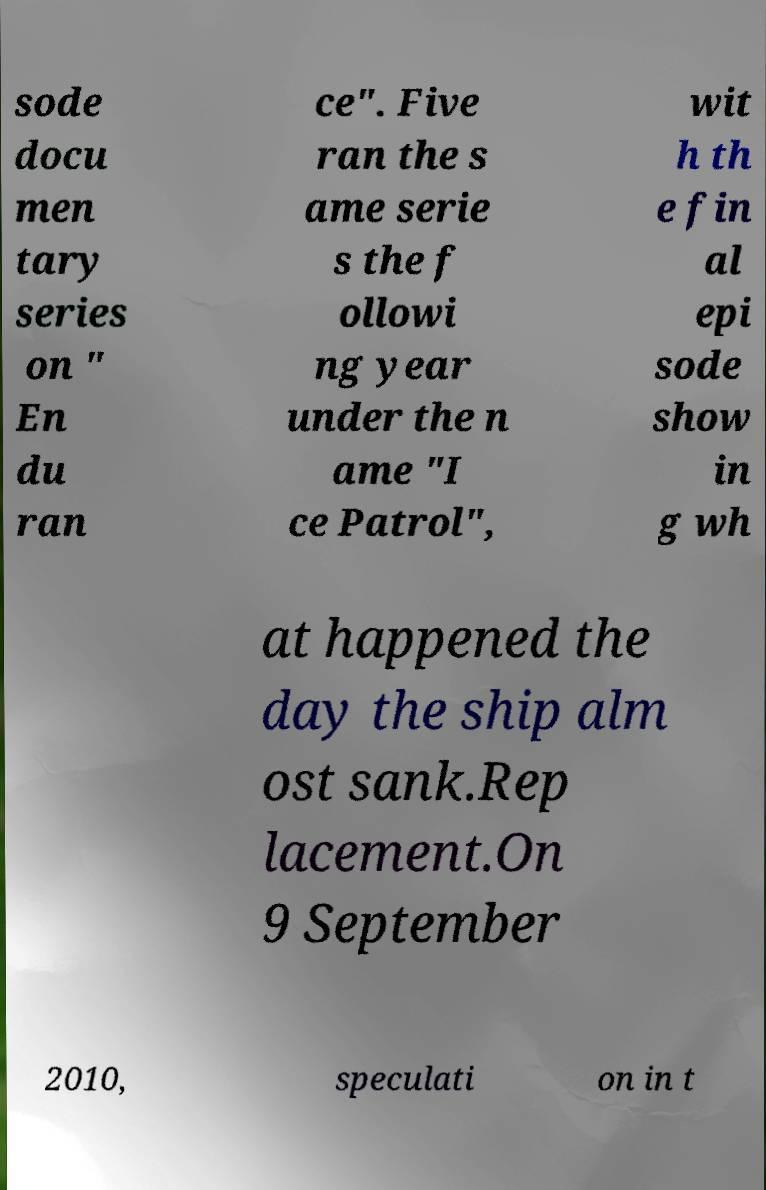I need the written content from this picture converted into text. Can you do that? sode docu men tary series on " En du ran ce". Five ran the s ame serie s the f ollowi ng year under the n ame "I ce Patrol", wit h th e fin al epi sode show in g wh at happened the day the ship alm ost sank.Rep lacement.On 9 September 2010, speculati on in t 